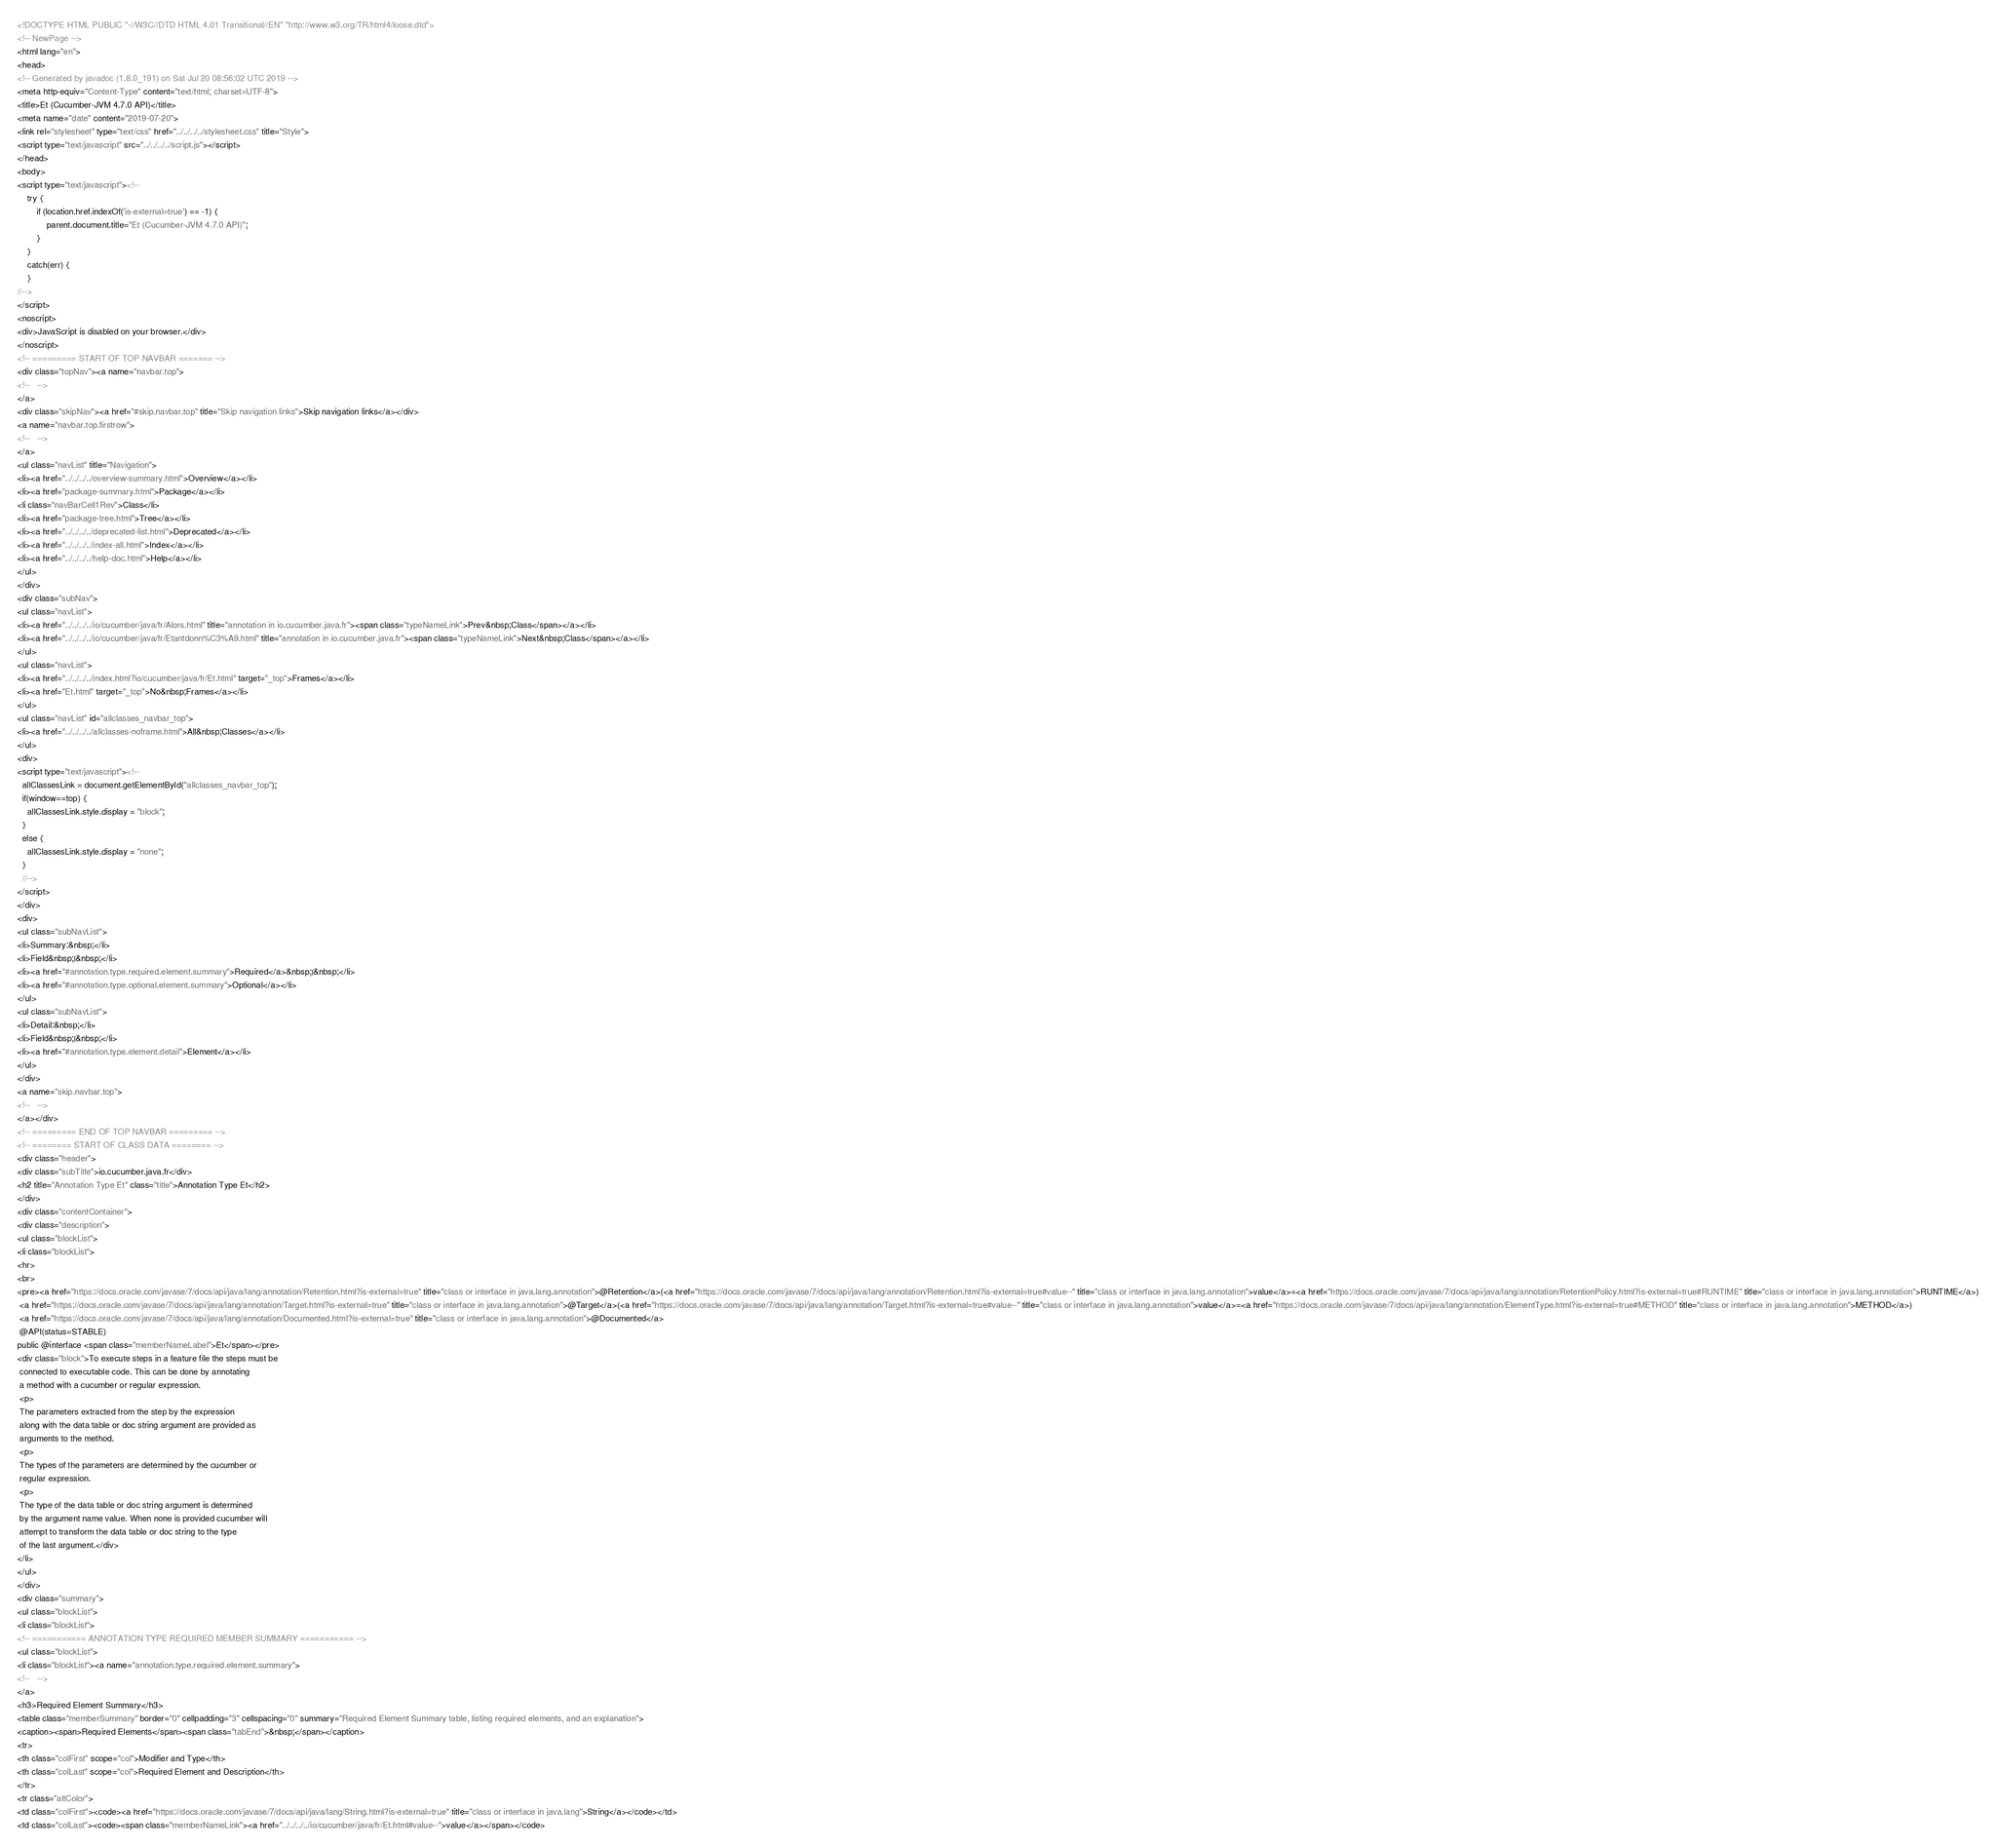Convert code to text. <code><loc_0><loc_0><loc_500><loc_500><_HTML_><!DOCTYPE HTML PUBLIC "-//W3C//DTD HTML 4.01 Transitional//EN" "http://www.w3.org/TR/html4/loose.dtd">
<!-- NewPage -->
<html lang="en">
<head>
<!-- Generated by javadoc (1.8.0_191) on Sat Jul 20 08:56:02 UTC 2019 -->
<meta http-equiv="Content-Type" content="text/html; charset=UTF-8">
<title>Et (Cucumber-JVM 4.7.0 API)</title>
<meta name="date" content="2019-07-20">
<link rel="stylesheet" type="text/css" href="../../../../stylesheet.css" title="Style">
<script type="text/javascript" src="../../../../script.js"></script>
</head>
<body>
<script type="text/javascript"><!--
    try {
        if (location.href.indexOf('is-external=true') == -1) {
            parent.document.title="Et (Cucumber-JVM 4.7.0 API)";
        }
    }
    catch(err) {
    }
//-->
</script>
<noscript>
<div>JavaScript is disabled on your browser.</div>
</noscript>
<!-- ========= START OF TOP NAVBAR ======= -->
<div class="topNav"><a name="navbar.top">
<!--   -->
</a>
<div class="skipNav"><a href="#skip.navbar.top" title="Skip navigation links">Skip navigation links</a></div>
<a name="navbar.top.firstrow">
<!--   -->
</a>
<ul class="navList" title="Navigation">
<li><a href="../../../../overview-summary.html">Overview</a></li>
<li><a href="package-summary.html">Package</a></li>
<li class="navBarCell1Rev">Class</li>
<li><a href="package-tree.html">Tree</a></li>
<li><a href="../../../../deprecated-list.html">Deprecated</a></li>
<li><a href="../../../../index-all.html">Index</a></li>
<li><a href="../../../../help-doc.html">Help</a></li>
</ul>
</div>
<div class="subNav">
<ul class="navList">
<li><a href="../../../../io/cucumber/java/fr/Alors.html" title="annotation in io.cucumber.java.fr"><span class="typeNameLink">Prev&nbsp;Class</span></a></li>
<li><a href="../../../../io/cucumber/java/fr/Etantdonn%C3%A9.html" title="annotation in io.cucumber.java.fr"><span class="typeNameLink">Next&nbsp;Class</span></a></li>
</ul>
<ul class="navList">
<li><a href="../../../../index.html?io/cucumber/java/fr/Et.html" target="_top">Frames</a></li>
<li><a href="Et.html" target="_top">No&nbsp;Frames</a></li>
</ul>
<ul class="navList" id="allclasses_navbar_top">
<li><a href="../../../../allclasses-noframe.html">All&nbsp;Classes</a></li>
</ul>
<div>
<script type="text/javascript"><!--
  allClassesLink = document.getElementById("allclasses_navbar_top");
  if(window==top) {
    allClassesLink.style.display = "block";
  }
  else {
    allClassesLink.style.display = "none";
  }
  //-->
</script>
</div>
<div>
<ul class="subNavList">
<li>Summary:&nbsp;</li>
<li>Field&nbsp;|&nbsp;</li>
<li><a href="#annotation.type.required.element.summary">Required</a>&nbsp;|&nbsp;</li>
<li><a href="#annotation.type.optional.element.summary">Optional</a></li>
</ul>
<ul class="subNavList">
<li>Detail:&nbsp;</li>
<li>Field&nbsp;|&nbsp;</li>
<li><a href="#annotation.type.element.detail">Element</a></li>
</ul>
</div>
<a name="skip.navbar.top">
<!--   -->
</a></div>
<!-- ========= END OF TOP NAVBAR ========= -->
<!-- ======== START OF CLASS DATA ======== -->
<div class="header">
<div class="subTitle">io.cucumber.java.fr</div>
<h2 title="Annotation Type Et" class="title">Annotation Type Et</h2>
</div>
<div class="contentContainer">
<div class="description">
<ul class="blockList">
<li class="blockList">
<hr>
<br>
<pre><a href="https://docs.oracle.com/javase/7/docs/api/java/lang/annotation/Retention.html?is-external=true" title="class or interface in java.lang.annotation">@Retention</a>(<a href="https://docs.oracle.com/javase/7/docs/api/java/lang/annotation/Retention.html?is-external=true#value--" title="class or interface in java.lang.annotation">value</a>=<a href="https://docs.oracle.com/javase/7/docs/api/java/lang/annotation/RetentionPolicy.html?is-external=true#RUNTIME" title="class or interface in java.lang.annotation">RUNTIME</a>)
 <a href="https://docs.oracle.com/javase/7/docs/api/java/lang/annotation/Target.html?is-external=true" title="class or interface in java.lang.annotation">@Target</a>(<a href="https://docs.oracle.com/javase/7/docs/api/java/lang/annotation/Target.html?is-external=true#value--" title="class or interface in java.lang.annotation">value</a>=<a href="https://docs.oracle.com/javase/7/docs/api/java/lang/annotation/ElementType.html?is-external=true#METHOD" title="class or interface in java.lang.annotation">METHOD</a>)
 <a href="https://docs.oracle.com/javase/7/docs/api/java/lang/annotation/Documented.html?is-external=true" title="class or interface in java.lang.annotation">@Documented</a>
 @API(status=STABLE)
public @interface <span class="memberNameLabel">Et</span></pre>
<div class="block">To execute steps in a feature file the steps must be
 connected to executable code. This can be done by annotating
 a method with a cucumber or regular expression.
 <p>
 The parameters extracted from the step by the expression
 along with the data table or doc string argument are provided as
 arguments to the method.
 <p>
 The types of the parameters are determined by the cucumber or
 regular expression.
 <p>
 The type of the data table or doc string argument is determined
 by the argument name value. When none is provided cucumber will
 attempt to transform the data table or doc string to the type
 of the last argument.</div>
</li>
</ul>
</div>
<div class="summary">
<ul class="blockList">
<li class="blockList">
<!-- =========== ANNOTATION TYPE REQUIRED MEMBER SUMMARY =========== -->
<ul class="blockList">
<li class="blockList"><a name="annotation.type.required.element.summary">
<!--   -->
</a>
<h3>Required Element Summary</h3>
<table class="memberSummary" border="0" cellpadding="3" cellspacing="0" summary="Required Element Summary table, listing required elements, and an explanation">
<caption><span>Required Elements</span><span class="tabEnd">&nbsp;</span></caption>
<tr>
<th class="colFirst" scope="col">Modifier and Type</th>
<th class="colLast" scope="col">Required Element and Description</th>
</tr>
<tr class="altColor">
<td class="colFirst"><code><a href="https://docs.oracle.com/javase/7/docs/api/java/lang/String.html?is-external=true" title="class or interface in java.lang">String</a></code></td>
<td class="colLast"><code><span class="memberNameLink"><a href="../../../../io/cucumber/java/fr/Et.html#value--">value</a></span></code></code> 